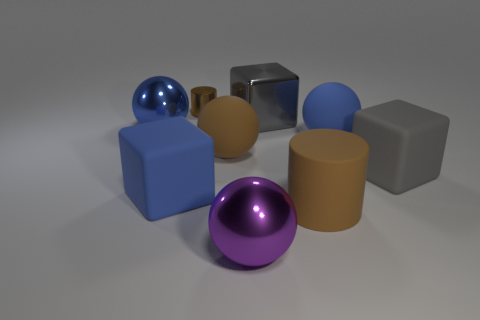There is a cylinder that is in front of the large blue metallic ball; does it have the same size as the brown cylinder that is left of the large gray shiny thing?
Ensure brevity in your answer.  No. What is the shape of the big metal object that is both in front of the big metallic cube and on the right side of the big brown ball?
Ensure brevity in your answer.  Sphere. Are there any other shiny cylinders that have the same color as the large cylinder?
Provide a short and direct response. Yes. Is there a large blue matte block?
Make the answer very short. Yes. There is a matte block left of the purple object; what color is it?
Ensure brevity in your answer.  Blue. Do the gray shiny cube and the brown matte object that is in front of the blue block have the same size?
Make the answer very short. Yes. What is the size of the block that is in front of the gray shiny block and on the right side of the big purple metal sphere?
Your answer should be very brief. Large. Are there any big purple things that have the same material as the large brown cylinder?
Keep it short and to the point. No. What shape is the small brown metal object?
Offer a very short reply. Cylinder. Is the blue metal object the same size as the metallic cylinder?
Provide a short and direct response. No. 